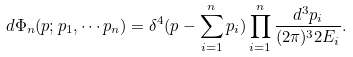<formula> <loc_0><loc_0><loc_500><loc_500>d \Phi _ { n } ( p ; p _ { 1 } , \cdots p _ { n } ) = \delta ^ { 4 } ( p - \sum ^ { n } _ { i = 1 } p _ { i } ) \prod ^ { n } _ { i = 1 } \frac { d ^ { 3 } { p } _ { i } } { ( 2 \pi ) ^ { 3 } 2 E _ { i } } .</formula> 